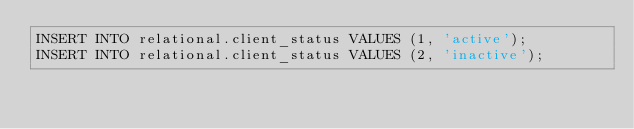<code> <loc_0><loc_0><loc_500><loc_500><_SQL_>INSERT INTO relational.client_status VALUES (1, 'active');
INSERT INTO relational.client_status VALUES (2, 'inactive');</code> 